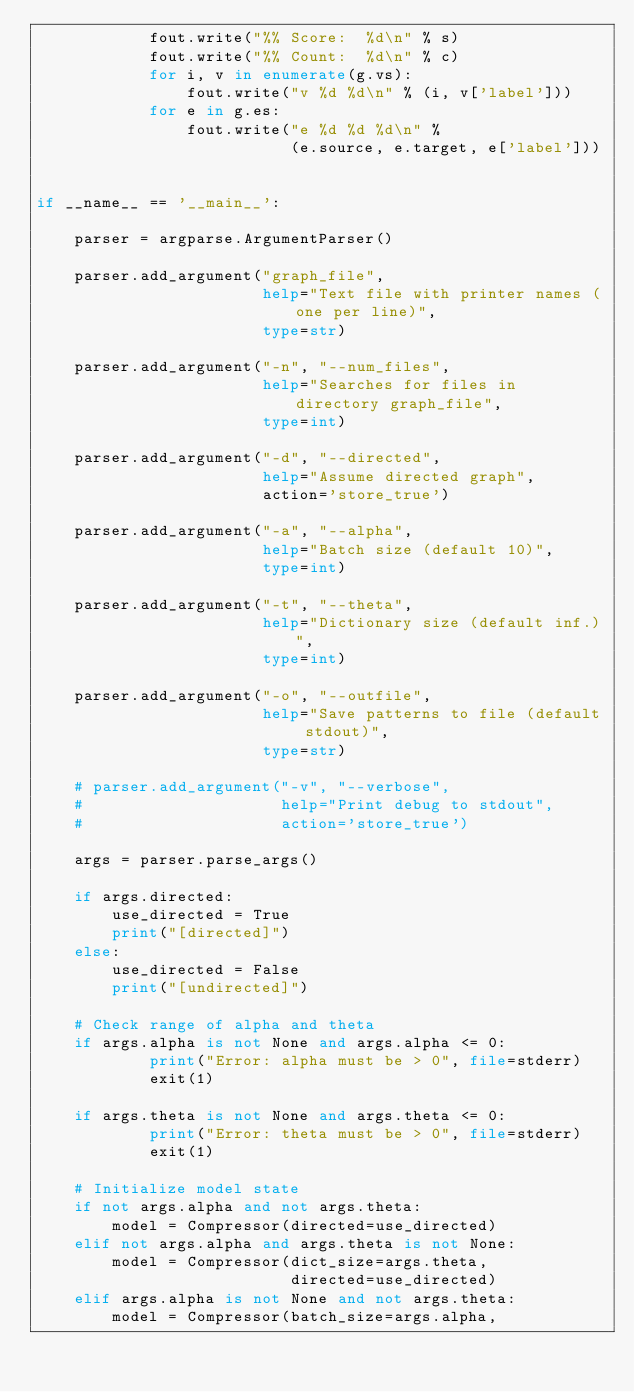Convert code to text. <code><loc_0><loc_0><loc_500><loc_500><_Python_>            fout.write("%% Score:  %d\n" % s)
            fout.write("%% Count:  %d\n" % c)
            for i, v in enumerate(g.vs):
                fout.write("v %d %d\n" % (i, v['label']))
            for e in g.es:
                fout.write("e %d %d %d\n" %
                           (e.source, e.target, e['label']))


if __name__ == '__main__':

    parser = argparse.ArgumentParser()

    parser.add_argument("graph_file",
                        help="Text file with printer names (one per line)",
                        type=str)

    parser.add_argument("-n", "--num_files",
                        help="Searches for files in directory graph_file",
                        type=int)

    parser.add_argument("-d", "--directed",
                        help="Assume directed graph",
                        action='store_true')

    parser.add_argument("-a", "--alpha",
                        help="Batch size (default 10)",
                        type=int)

    parser.add_argument("-t", "--theta",
                        help="Dictionary size (default inf.)",
                        type=int)

    parser.add_argument("-o", "--outfile",
                        help="Save patterns to file (default stdout)",
                        type=str)

    # parser.add_argument("-v", "--verbose",
    #                     help="Print debug to stdout",
    #                     action='store_true')

    args = parser.parse_args()

    if args.directed:
        use_directed = True
        print("[directed]")
    else:
        use_directed = False
        print("[undirected]")

    # Check range of alpha and theta
    if args.alpha is not None and args.alpha <= 0:
            print("Error: alpha must be > 0", file=stderr)
            exit(1)

    if args.theta is not None and args.theta <= 0:
            print("Error: theta must be > 0", file=stderr)
            exit(1)

    # Initialize model state
    if not args.alpha and not args.theta:
        model = Compressor(directed=use_directed)
    elif not args.alpha and args.theta is not None:
        model = Compressor(dict_size=args.theta,
                           directed=use_directed)
    elif args.alpha is not None and not args.theta:
        model = Compressor(batch_size=args.alpha,</code> 